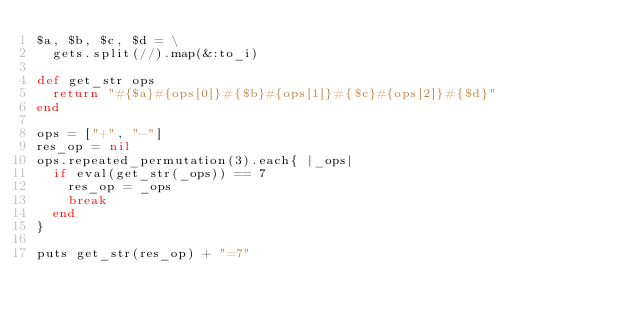Convert code to text. <code><loc_0><loc_0><loc_500><loc_500><_Ruby_>$a, $b, $c, $d = \
  gets.split(//).map(&:to_i)

def get_str ops
  return "#{$a}#{ops[0]}#{$b}#{ops[1]}#{$c}#{ops[2]}#{$d}"
end

ops = ["+", "-"]
res_op = nil
ops.repeated_permutation(3).each{ |_ops|
  if eval(get_str(_ops)) == 7
    res_op = _ops
    break
  end
}

puts get_str(res_op) + "=7"</code> 